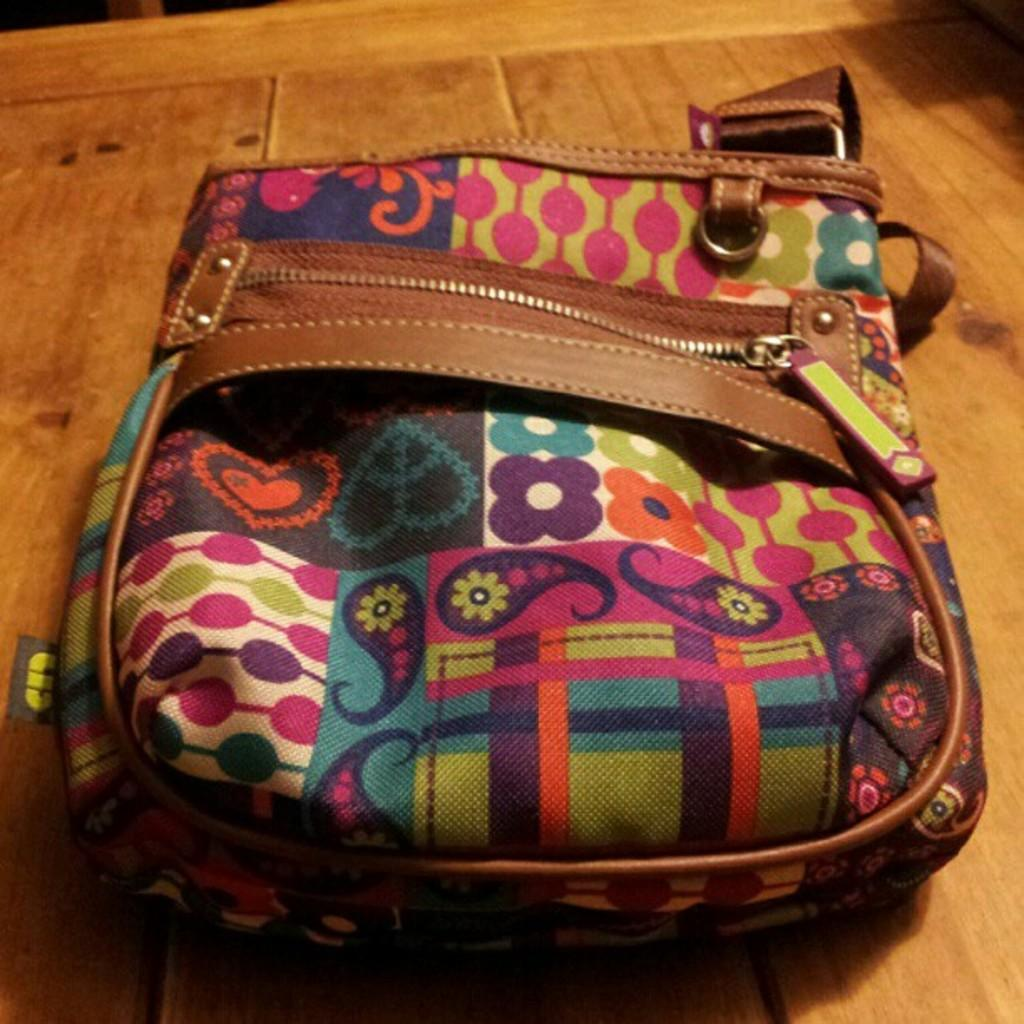What type of bag is in the picture? There is a multi-colored bag in the picture. What can be seen on the bag? The bag has various arts on it. How can the bag be secured? There is a chain to hold the bag. What is the bag placed on? The bag is placed on a brown-colored table. How many basketballs are being juggled by the crowd in the image? There is no crowd or basketballs present in the image. 